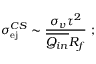Convert formula to latex. <formula><loc_0><loc_0><loc_500><loc_500>\sigma _ { e j } ^ { C S } \sim \frac { \sigma _ { v } \tau ^ { 2 } } { \overline { { Q _ { i n } } } R _ { f } } ;</formula> 